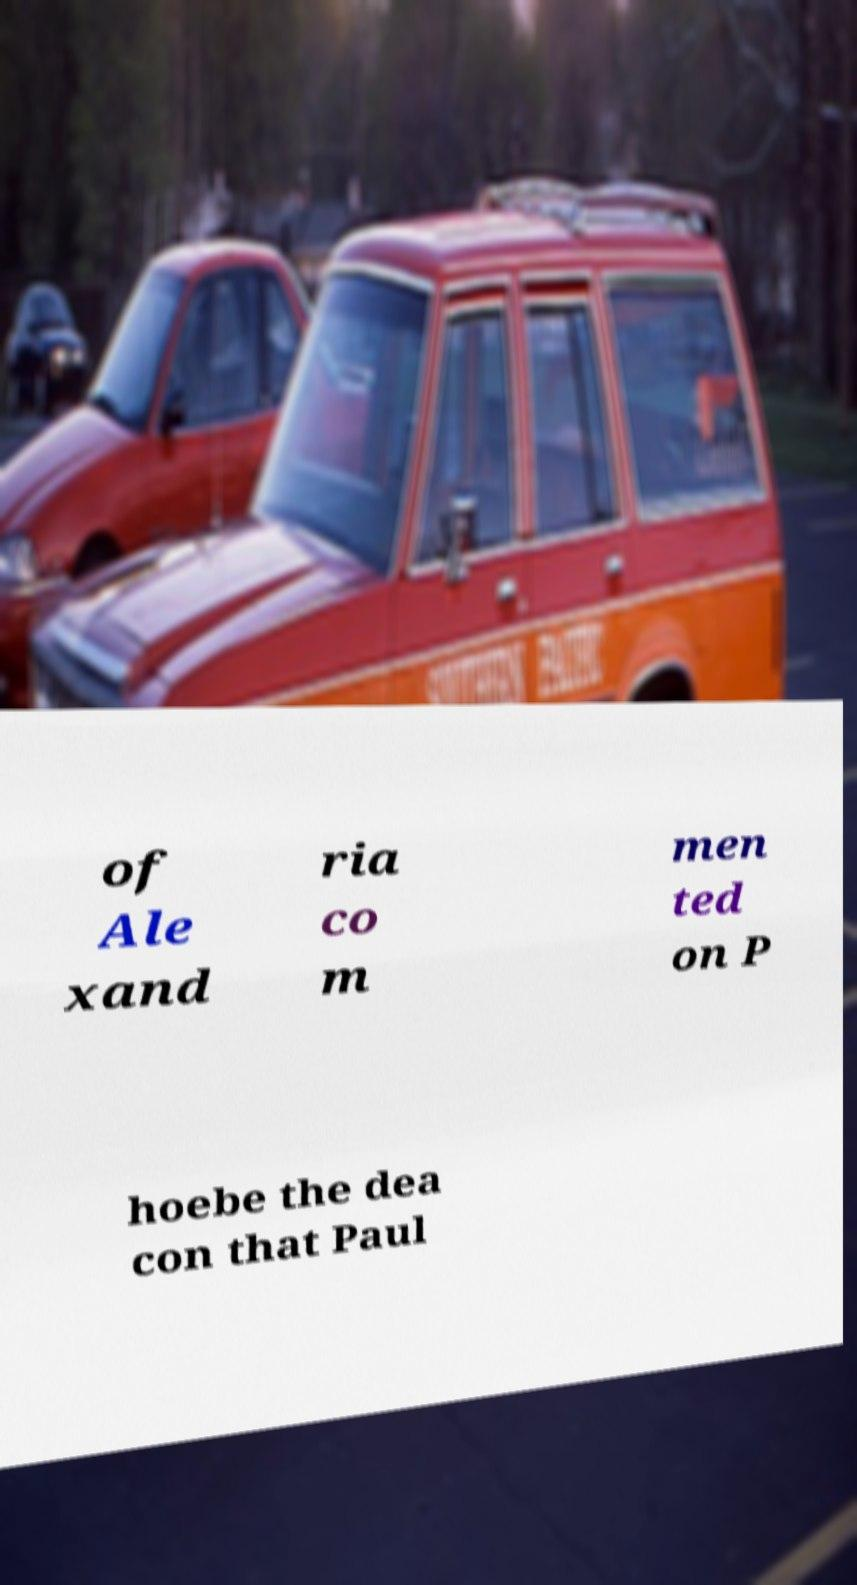What messages or text are displayed in this image? I need them in a readable, typed format. of Ale xand ria co m men ted on P hoebe the dea con that Paul 